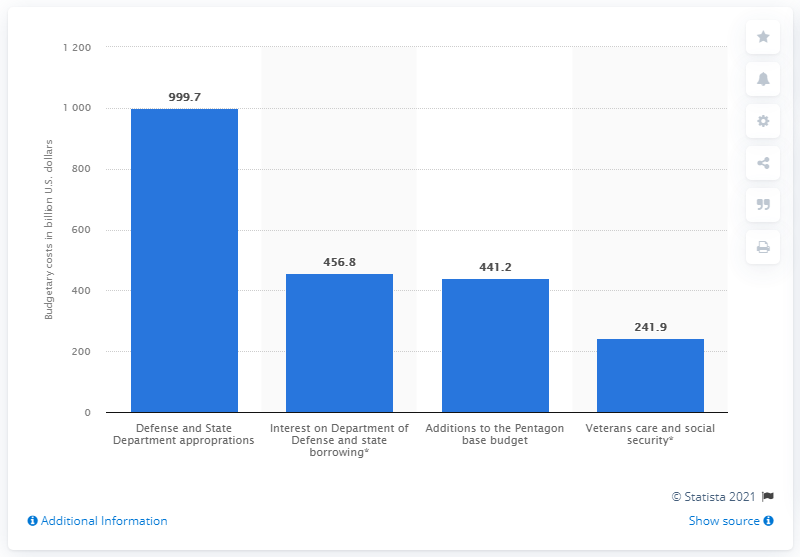Identify some key points in this picture. The interest on additional borrowing alone cost the United States 456.8. The United States has spent $456.8 million on Afghanistan since 9/11. 